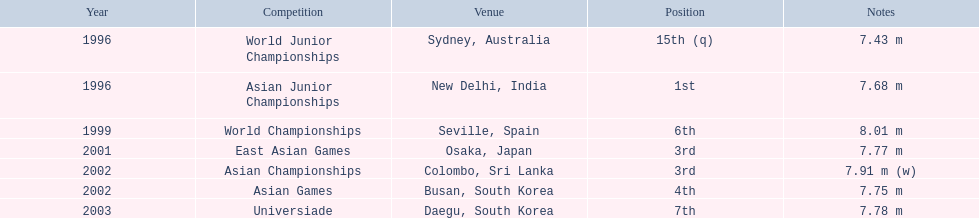What was the venue when he placed first? New Delhi, India. 